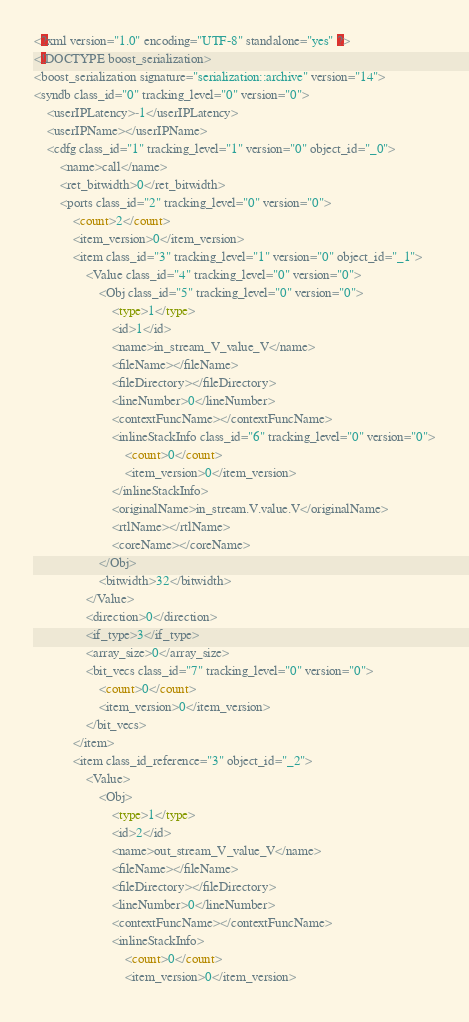Convert code to text. <code><loc_0><loc_0><loc_500><loc_500><_Ada_><?xml version="1.0" encoding="UTF-8" standalone="yes" ?>
<!DOCTYPE boost_serialization>
<boost_serialization signature="serialization::archive" version="14">
<syndb class_id="0" tracking_level="0" version="0">
	<userIPLatency>-1</userIPLatency>
	<userIPName></userIPName>
	<cdfg class_id="1" tracking_level="1" version="0" object_id="_0">
		<name>call</name>
		<ret_bitwidth>0</ret_bitwidth>
		<ports class_id="2" tracking_level="0" version="0">
			<count>2</count>
			<item_version>0</item_version>
			<item class_id="3" tracking_level="1" version="0" object_id="_1">
				<Value class_id="4" tracking_level="0" version="0">
					<Obj class_id="5" tracking_level="0" version="0">
						<type>1</type>
						<id>1</id>
						<name>in_stream_V_value_V</name>
						<fileName></fileName>
						<fileDirectory></fileDirectory>
						<lineNumber>0</lineNumber>
						<contextFuncName></contextFuncName>
						<inlineStackInfo class_id="6" tracking_level="0" version="0">
							<count>0</count>
							<item_version>0</item_version>
						</inlineStackInfo>
						<originalName>in_stream.V.value.V</originalName>
						<rtlName></rtlName>
						<coreName></coreName>
					</Obj>
					<bitwidth>32</bitwidth>
				</Value>
				<direction>0</direction>
				<if_type>3</if_type>
				<array_size>0</array_size>
				<bit_vecs class_id="7" tracking_level="0" version="0">
					<count>0</count>
					<item_version>0</item_version>
				</bit_vecs>
			</item>
			<item class_id_reference="3" object_id="_2">
				<Value>
					<Obj>
						<type>1</type>
						<id>2</id>
						<name>out_stream_V_value_V</name>
						<fileName></fileName>
						<fileDirectory></fileDirectory>
						<lineNumber>0</lineNumber>
						<contextFuncName></contextFuncName>
						<inlineStackInfo>
							<count>0</count>
							<item_version>0</item_version></code> 